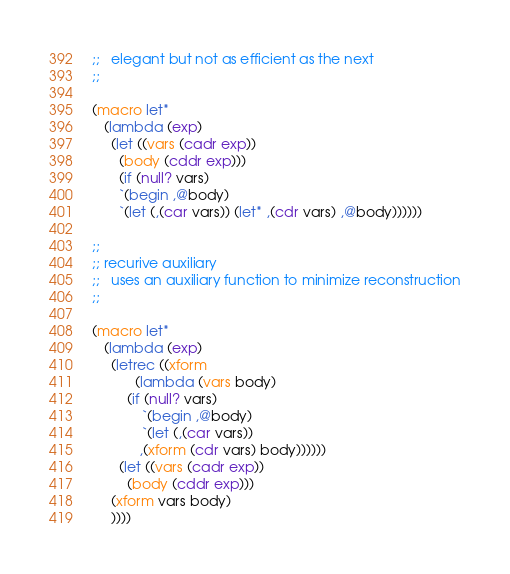Convert code to text. <code><loc_0><loc_0><loc_500><loc_500><_Scheme_>;;   elegant but not as efficient as the next
;;

(macro let*
   (lambda (exp)
     (let ((vars (cadr exp))
	   (body (cddr exp)))
       (if (null? vars)
	   `(begin ,@body)
	   `(let (,(car vars)) (let* ,(cdr vars) ,@body))))))

;;
;; recurive auxiliary
;;   uses an auxiliary function to minimize reconstruction
;;

(macro let*
   (lambda (exp)
     (letrec ((xform
	       (lambda (vars body)
		 (if (null? vars)
		     `(begin ,@body)
		     `(let (,(car vars))
			,(xform (cdr vars) body))))))
       (let ((vars (cadr exp))
	     (body (cddr exp)))
	 (xform vars body)
	 ))))
</code> 